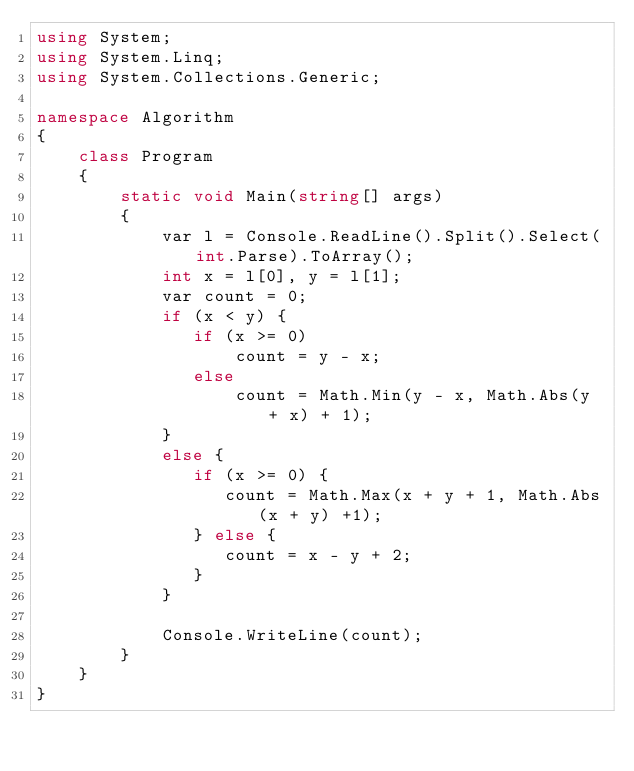Convert code to text. <code><loc_0><loc_0><loc_500><loc_500><_C#_>using System;
using System.Linq;
using System.Collections.Generic;

namespace Algorithm
{
    class Program
    {
        static void Main(string[] args)
        {
            var l = Console.ReadLine().Split().Select(int.Parse).ToArray();
            int x = l[0], y = l[1];
            var count = 0;
            if (x < y) {
               if (x >= 0) 
                   count = y - x;
               else
                   count = Math.Min(y - x, Math.Abs(y + x) + 1);
            }
            else {
               if (x >= 0) {
                  count = Math.Max(x + y + 1, Math.Abs(x + y) +1); 
               } else {
                  count = x - y + 2;
               }
            }
            
            Console.WriteLine(count);
        }
    }
}
</code> 